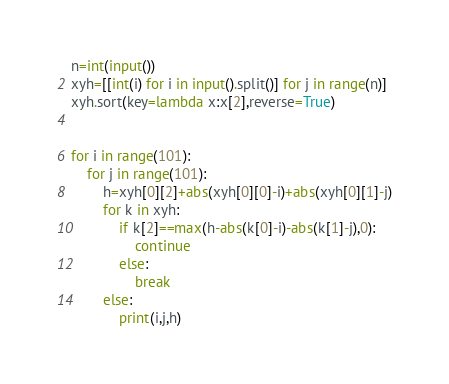Convert code to text. <code><loc_0><loc_0><loc_500><loc_500><_Python_>n=int(input())
xyh=[[int(i) for i in input().split()] for j in range(n)]
xyh.sort(key=lambda x:x[2],reverse=True)


for i in range(101):
    for j in range(101):
        h=xyh[0][2]+abs(xyh[0][0]-i)+abs(xyh[0][1]-j)
        for k in xyh:
            if k[2]==max(h-abs(k[0]-i)-abs(k[1]-j),0):
                continue
            else:
                break
        else:
            print(i,j,h)
</code> 